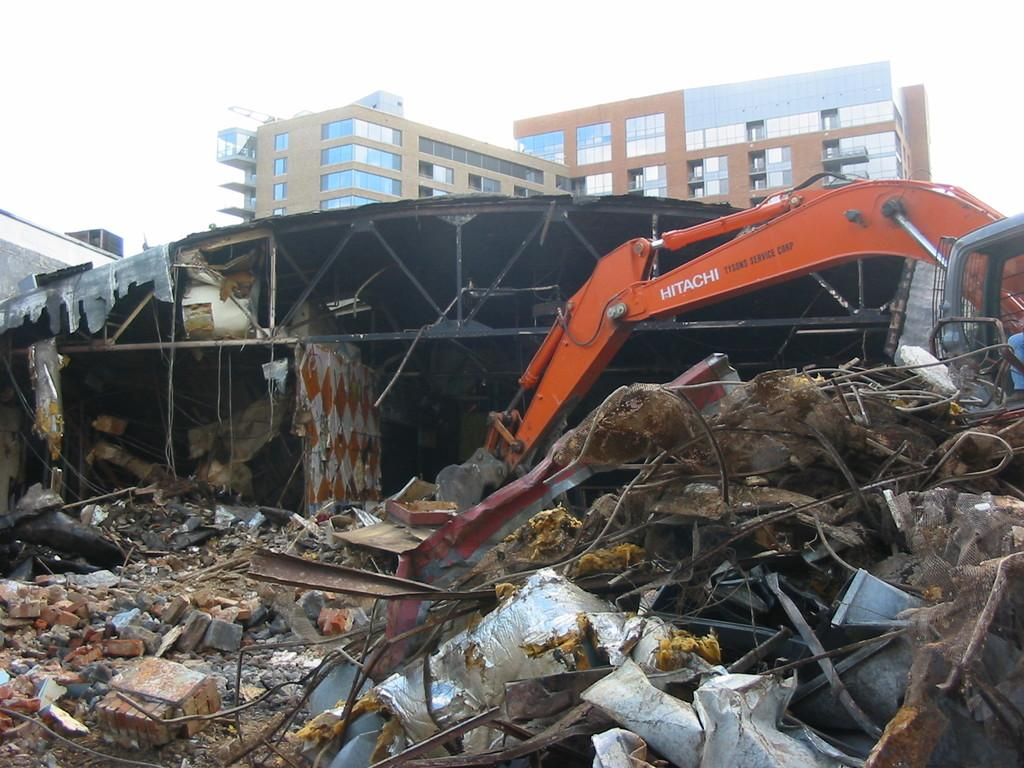What can be seen on the ground in the image? There is scrap on the ground in the image. What type of natural elements are visible in the image? There are stones visible in the image. What man-made objects are present in the image? Wires and an excavator are present in the image. What type of structure is visible in the image? A roof is visible in the image. What can be seen in the background of the image? There are buildings with windows and the sky visible in the background of the image. What type of weather can be seen in the image? The provided facts do not mention any weather conditions, so it cannot be determined from the image. Is there a prison visible in the image? There is no mention of a prison in the provided facts, and therefore it cannot be determined from the image. 